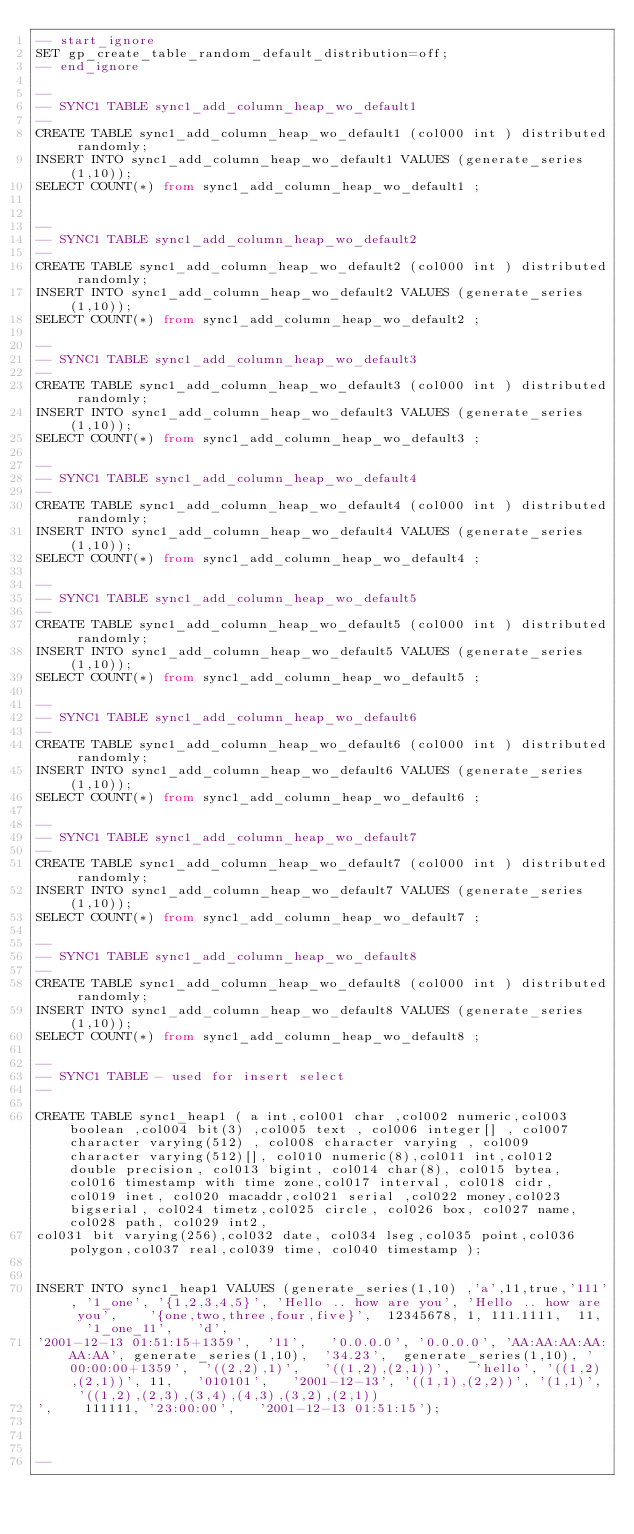<code> <loc_0><loc_0><loc_500><loc_500><_SQL_>-- start_ignore
SET gp_create_table_random_default_distribution=off;
-- end_ignore

--
-- SYNC1 TABLE sync1_add_column_heap_wo_default1
--
CREATE TABLE sync1_add_column_heap_wo_default1 (col000 int ) distributed randomly;
INSERT INTO sync1_add_column_heap_wo_default1 VALUES (generate_series(1,10));
SELECT COUNT(*) from sync1_add_column_heap_wo_default1 ;


--
-- SYNC1 TABLE sync1_add_column_heap_wo_default2
--
CREATE TABLE sync1_add_column_heap_wo_default2 (col000 int ) distributed randomly;
INSERT INTO sync1_add_column_heap_wo_default2 VALUES (generate_series(1,10));
SELECT COUNT(*) from sync1_add_column_heap_wo_default2 ;

--
-- SYNC1 TABLE sync1_add_column_heap_wo_default3
--
CREATE TABLE sync1_add_column_heap_wo_default3 (col000 int ) distributed randomly;
INSERT INTO sync1_add_column_heap_wo_default3 VALUES (generate_series(1,10));
SELECT COUNT(*) from sync1_add_column_heap_wo_default3 ;

--
-- SYNC1 TABLE sync1_add_column_heap_wo_default4
--
CREATE TABLE sync1_add_column_heap_wo_default4 (col000 int ) distributed randomly;
INSERT INTO sync1_add_column_heap_wo_default4 VALUES (generate_series(1,10));
SELECT COUNT(*) from sync1_add_column_heap_wo_default4 ;

--
-- SYNC1 TABLE sync1_add_column_heap_wo_default5
--
CREATE TABLE sync1_add_column_heap_wo_default5 (col000 int ) distributed randomly;
INSERT INTO sync1_add_column_heap_wo_default5 VALUES (generate_series(1,10));
SELECT COUNT(*) from sync1_add_column_heap_wo_default5 ;

--
-- SYNC1 TABLE sync1_add_column_heap_wo_default6
--
CREATE TABLE sync1_add_column_heap_wo_default6 (col000 int ) distributed randomly;
INSERT INTO sync1_add_column_heap_wo_default6 VALUES (generate_series(1,10));
SELECT COUNT(*) from sync1_add_column_heap_wo_default6 ;

--
-- SYNC1 TABLE sync1_add_column_heap_wo_default7
--
CREATE TABLE sync1_add_column_heap_wo_default7 (col000 int ) distributed randomly;
INSERT INTO sync1_add_column_heap_wo_default7 VALUES (generate_series(1,10));
SELECT COUNT(*) from sync1_add_column_heap_wo_default7 ;

--
-- SYNC1 TABLE sync1_add_column_heap_wo_default8
--
CREATE TABLE sync1_add_column_heap_wo_default8 (col000 int ) distributed randomly;
INSERT INTO sync1_add_column_heap_wo_default8 VALUES (generate_series(1,10));
SELECT COUNT(*) from sync1_add_column_heap_wo_default8 ;

--
-- SYNC1 TABLE - used for insert select
--

CREATE TABLE sync1_heap1 ( a int,col001 char ,col002 numeric,col003 boolean ,col004 bit(3) ,col005 text , col006 integer[] , col007 character varying(512) , col008 character varying , col009 character varying(512)[], col010 numeric(8),col011 int,col012 double precision, col013 bigint, col014 char(8), col015 bytea,col016 timestamp with time zone,col017 interval, col018 cidr, col019 inet, col020 macaddr,col021 serial ,col022 money,col023 bigserial, col024 timetz,col025 circle, col026 box, col027 name,col028 path, col029 int2, 
col031 bit varying(256),col032 date, col034 lseg,col035 point,col036 polygon,col037 real,col039 time, col040 timestamp );


INSERT INTO sync1_heap1 VALUES (generate_series(1,10) ,'a',11,true,'111', '1_one', '{1,2,3,4,5}', 'Hello .. how are you', 'Hello .. how are you',    '{one,two,three,four,five}',  12345678, 1, 111.1111,  11,  '1_one_11',   'd',
'2001-12-13 01:51:15+1359',  '11',   '0.0.0.0', '0.0.0.0', 'AA:AA:AA:AA:AA:AA', generate_series(1,10),  '34.23',  generate_series(1,10), '00:00:00+1359',  '((2,2),1)',   '((1,2),(2,1))',   'hello', '((1,2),(2,1))', 11,   '010101',   '2001-12-13', '((1,1),(2,2))', '(1,1)', '((1,2),(2,3),(3,4),(4,3),(3,2),(2,1))
',    111111, '23:00:00',   '2001-12-13 01:51:15');



--</code> 